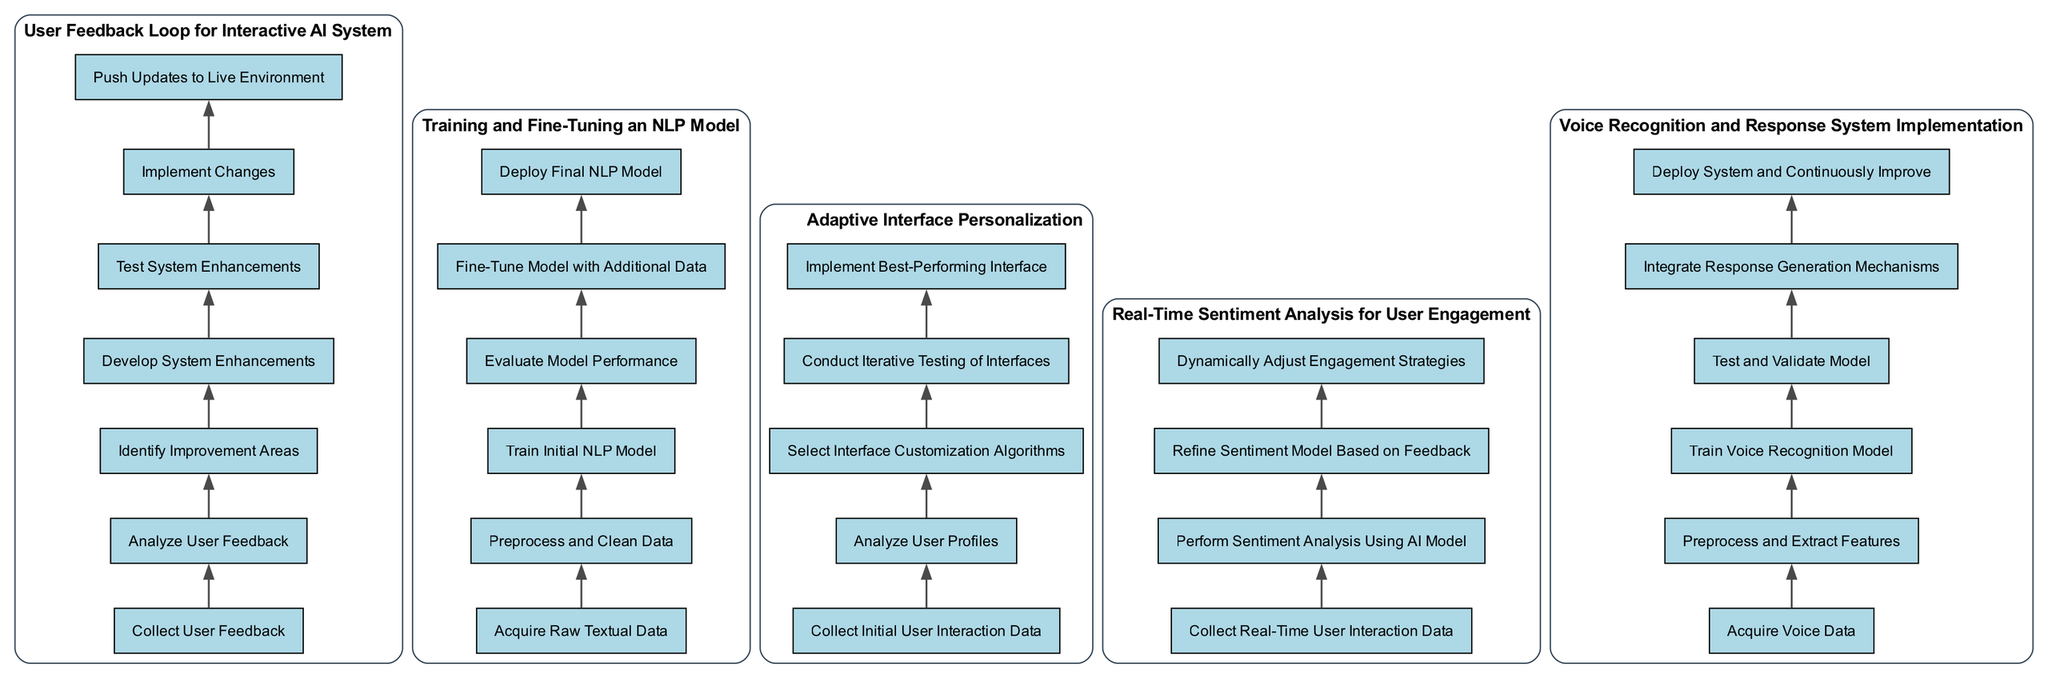What are the first steps in the User Feedback Loop? The first two steps in the User Feedback Loop are "Collect User Feedback" and "Analyze User Feedback." These are listed at the bottom of the flowchart and represent the starting point of the process.
Answer: Collect User Feedback, Analyze User Feedback How many steps are there in the Training and Fine-Tuning an NLP Model workflow? The workflow consists of six steps, as indicated in the diagram. Each step is laid out sequentially, starting from data acquisition and ending in deployment.
Answer: 6 Which workflow has the most steps? Upon comparing the workflows, the "User Feedback Loop for Interactive AI System" has seven steps, making it the workflow with the most components in the diagram.
Answer: User Feedback Loop for Interactive AI System What follows "Test System Enhancements" in the User Feedback Loop? According to the diagram, the step that follows "Test System Enhancements" is "Implement Changes." This indicates a direct progression from testing to the implementation phase.
Answer: Implement Changes In how many workflows does "Collect" appear as a step? The term "Collect" appears in four different workflows: "User Feedback Loop," "Adaptive Interface Personalization," "Real-Time Sentiment Analysis," and "Voice Recognition." Thus, it is present in four workflows of the diagram.
Answer: 4 Which step comes after "Preprocess and Clean Data" in the Training and Fine-Tuning an NLP Model workflow? The step that follows "Preprocess and Clean Data" is "Train Initial NLP Model." This defines a logical sequence in the data processing and model training phase.
Answer: Train Initial NLP Model What is the last step in the Adaptive Interface Personalization process? The final step in the Adaptive Interface Personalization process is "Implement Best-Performing Interface." This indicates the conclusion of the iterative process described in the flowchart.
Answer: Implement Best-Performing Interface How many distinct workflows are depicted in the diagram? The diagram showcases a total of five different workflows, each representing unique processes within AI systems. Each workflow is clearly labeled and flows independently.
Answer: 5 